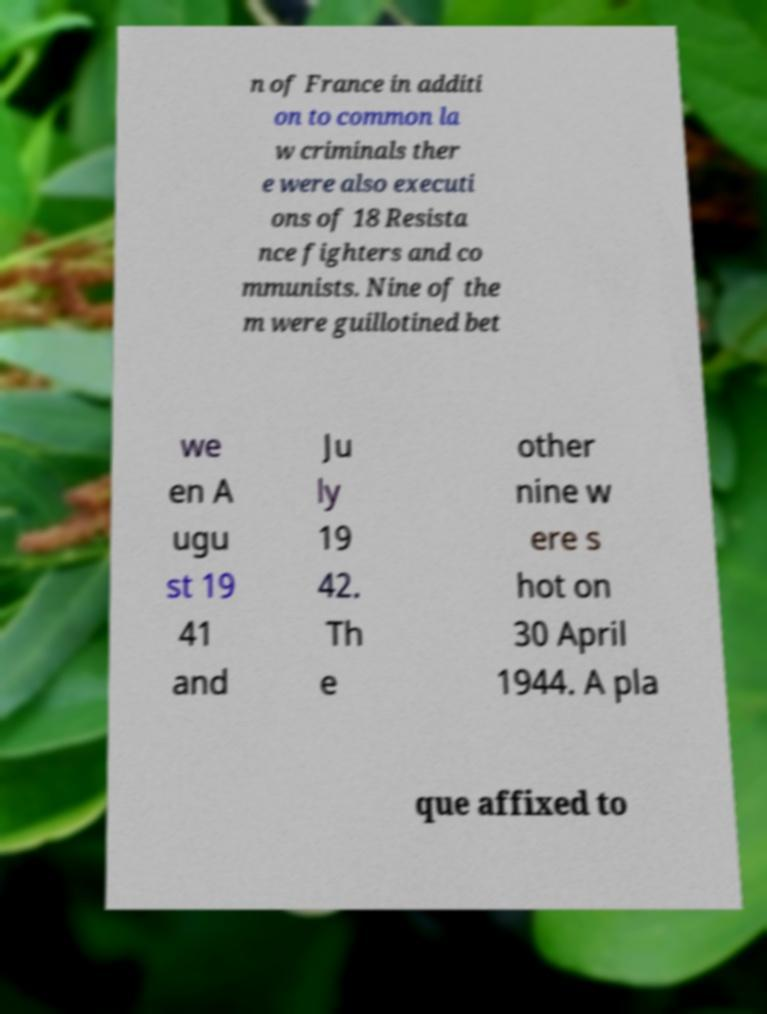Please read and relay the text visible in this image. What does it say? n of France in additi on to common la w criminals ther e were also executi ons of 18 Resista nce fighters and co mmunists. Nine of the m were guillotined bet we en A ugu st 19 41 and Ju ly 19 42. Th e other nine w ere s hot on 30 April 1944. A pla que affixed to 